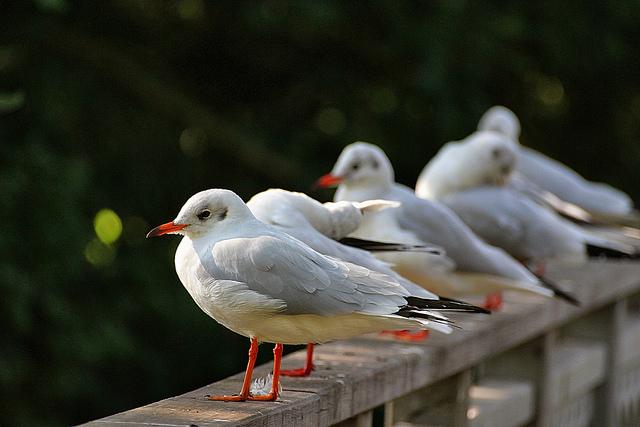How many breaks are there?
Write a very short answer. 2. Are these birds looking at each other?
Be succinct. No. What color are their legs?
Be succinct. Orange. What color are the birds?
Concise answer only. White. How many birds are there?
Concise answer only. 5. 